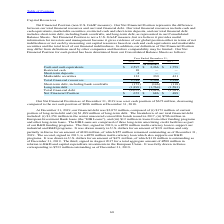According to Stmicroelectronics's financial document, What was the company's net cash position as of December 31, 2019? According to the financial document, $672 million. The relevant text states: "as of December 31, 2019 was a net cash position of $672 million, decreasing compared to the net cash position of $686 million at December 31, 2018...." Also, What was the financial debt comprised of as at December 31, 2019? (i) $173 million of current portion of long-term debt and (ii) $1,899 million of long-term debt.. The document states: "our financial debt was $2,072 million, composed of (i) $173 million of current portion of long-term debt and (ii) $1,899 million of long-term debt. Th..." Also, What was the first EIB loan amount that was signed? According to the financial document, €350 million. The relevant text states: "funding programs. The first, signed in 2010, is a €350 million multi-currency loan to support our industrial and R&D programs. It was drawn mainly in U.S. dollars..." Also, can you calculate: What was the increase / (decrease) in cash and cash equivalents from 2018 to 2019? Based on the calculation: 2,597 - 2,266, the result is 331 (in millions). This is based on the information: "Cash and cash equivalents $ 2,597 $ 2,266 $ 1,759 Cash and cash equivalents $ 2,597 $ 2,266 $ 1,759..." The key data points involved are: 2,266, 2,597. Also, can you calculate: What is the average restricted cash? To answer this question, I need to perform calculations using the financial data. The calculation is: (10 + 0 + 0) / 3, which equals 3.33 (in millions). This is based on the information: "Restricted cash 10 — — Restricted cash 10 — —..." The key data points involved are: 0, 10. Also, can you calculate: What is the percentage increase / (decrease) in the Total financial resources from 2018 to 2019? To answer this question, I need to perform calculations using the financial data. The calculation is: 2,744 / 2,596 - 1, which equals 5.7 (percentage). This is based on the information: "Total financial resources 2,744 2,596 2,190 Total financial resources 2,744 2,596 2,190..." The key data points involved are: 2,596, 2,744. 